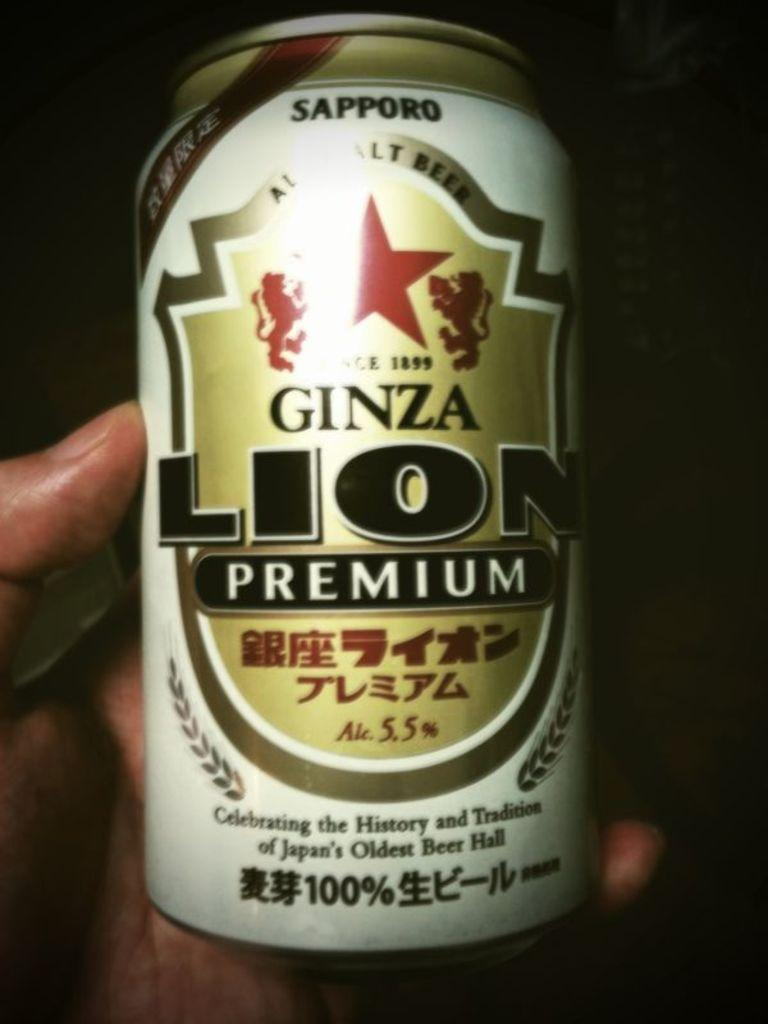What is the person in the image holding? The person is holding a can in the image. What can be found on the can besides the person holding it? There is text, numbers, and images on the can. What is the color of the background in the image? The background of the image is dark. What type of chalk is being used to write on the machine in the image? There is no chalk or machine present in the image. 